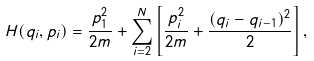Convert formula to latex. <formula><loc_0><loc_0><loc_500><loc_500>H ( q _ { i } , p _ { i } ) = \frac { p _ { 1 } ^ { 2 } } { 2 m } + \sum _ { i = 2 } ^ { N } \left [ \frac { p _ { i } ^ { 2 } } { 2 m } + \frac { ( q _ { i } - q _ { i - 1 } ) ^ { 2 } } { 2 } \right ] ,</formula> 